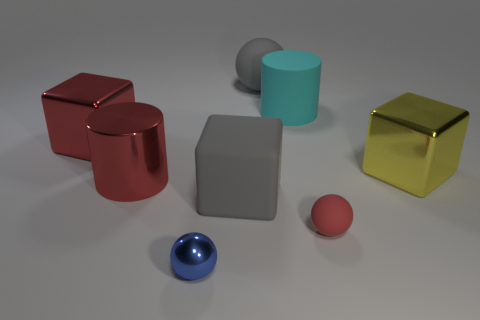What can you infer about the lighting condition in the scene? The lighting in the scene seems to be soft and diffused, resulting in gentle shadows and subtle reflections on the surfaces. This could indicate an indoor setting with a well-distributed light source, perhaps from studio lighting equipment meant to minimize harsh shadows and create a neutral background for showcasing the objects. 